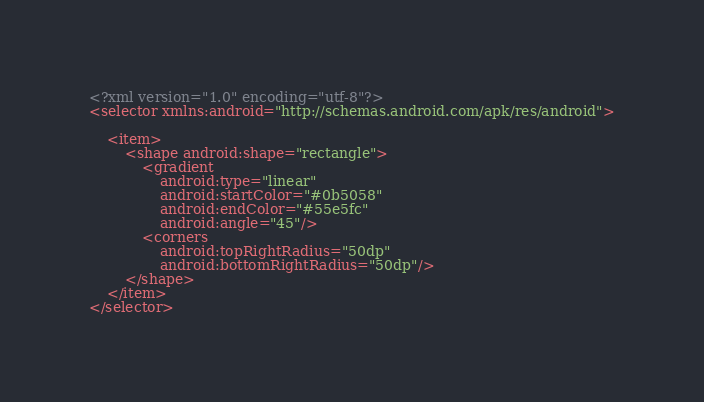Convert code to text. <code><loc_0><loc_0><loc_500><loc_500><_XML_><?xml version="1.0" encoding="utf-8"?>
<selector xmlns:android="http://schemas.android.com/apk/res/android">

    <item>
        <shape android:shape="rectangle">
            <gradient
                android:type="linear"
                android:startColor="#0b5058"
                android:endColor="#55e5fc"
                android:angle="45"/>
            <corners
                android:topRightRadius="50dp"
                android:bottomRightRadius="50dp"/>
        </shape>
    </item>
</selector></code> 